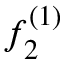Convert formula to latex. <formula><loc_0><loc_0><loc_500><loc_500>f _ { 2 } ^ { ( 1 ) }</formula> 